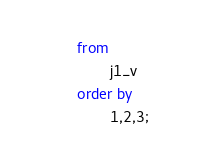Convert code to text. <code><loc_0><loc_0><loc_500><loc_500><_SQL_>from 
        j1_v
order by
        1,2,3;   
</code> 